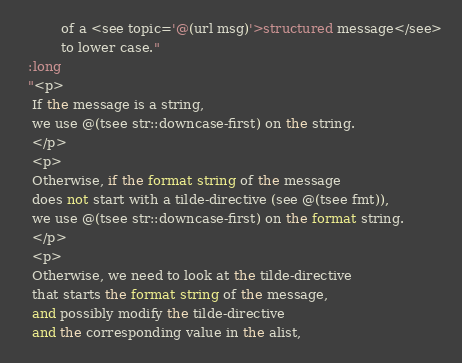Convert code to text. <code><loc_0><loc_0><loc_500><loc_500><_Lisp_>          of a <see topic='@(url msg)'>structured message</see>
          to lower case."
  :long
  "<p>
   If the message is a string,
   we use @(tsee str::downcase-first) on the string.
   </p>
   <p>
   Otherwise, if the format string of the message
   does not start with a tilde-directive (see @(tsee fmt)),
   we use @(tsee str::downcase-first) on the format string.
   </p>
   <p>
   Otherwise, we need to look at the tilde-directive
   that starts the format string of the message,
   and possibly modify the tilde-directive
   and the corresponding value in the alist,</code> 